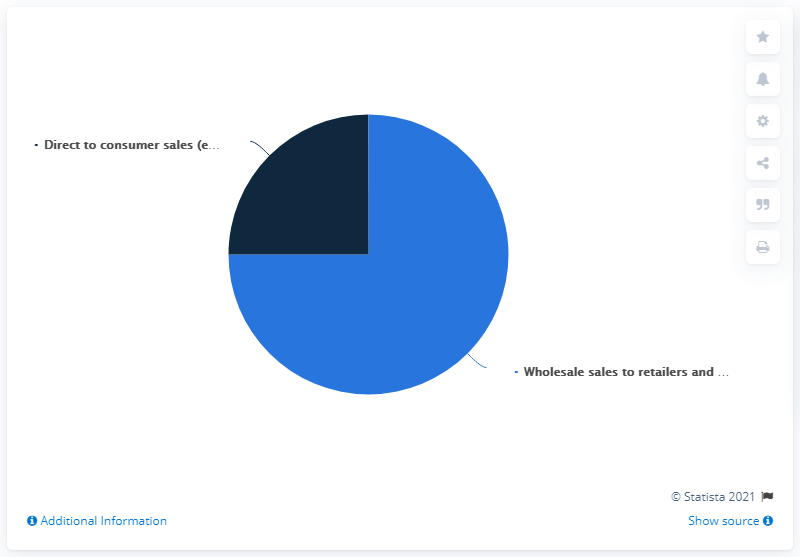Specify some key components in this picture. Wholesale sales to retailers typically account for approximately one-third of a retailer's total sales. Direct-to-consumer sales, represented by the color navy blue, are an increasingly popular and efficient way for companies to reach customers without the need for intermediaries. 